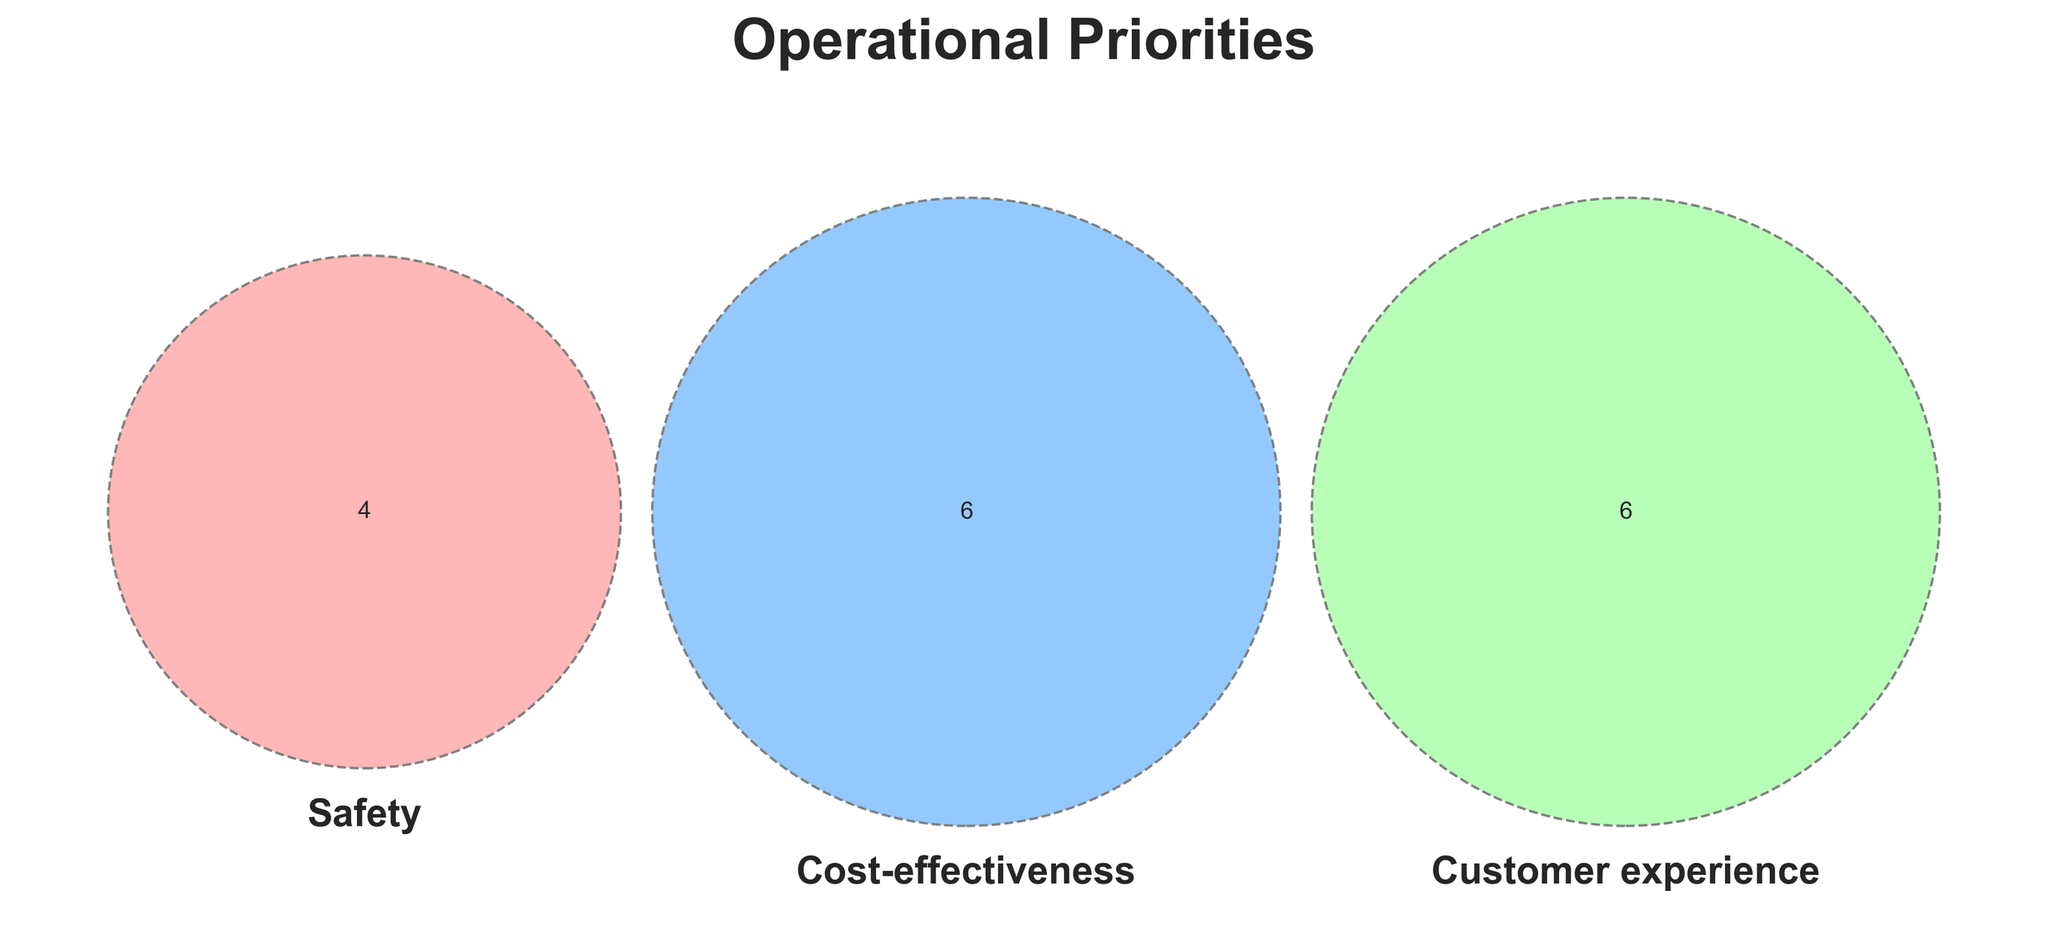How many priorities are unique to Safety? To determine this, we look at the area in the Venn diagram exclusively for Safety, which means not overlapping with Cost-effectiveness and Customer experience. These are "Emergency protocols", "Staff training", "Risk assessment", and "Evacuation plans".
Answer: 4 Which priorities are shared between Safety and Cost-effectiveness, but not Customer experience? This requires checking the overlap area between Safety and Cost-effectiveness that excludes Customer experience. In the Venn diagram, there are no elements in this overlapping section.
Answer: None What are the priorities that fall under Customer experience alone? We need to locate the area of the Venn diagram exclusive to Customer experience. These are "Personalized service", "Complaint resolution", "Guest feedback system", "Comfort amenities", and "Tailored itineraries".
Answer: 5 Are there any priorities shared by all three categories: Safety, Cost-effectiveness, and Customer experience? The center of the Venn diagram represents the intersection of all three categories. Since there is no mention of such an area in the dataset or the diagram, there are no shared priorities among all three.
Answer: None How many priorities are related to Cost-effectiveness, either exclusively or shared with other categories? This involves summing up all areas that include Cost-effectiveness. The priorities here are "Budget control", "Efficient resource allocation", "Vendor negotiations", "Cost-benefit analysis", "Inventory management", and "Bulk purchasing".
Answer: 6 Which category has the most unique priorities? By directly comparing the exclusive areas of each category in the Venn diagram. Safety has 4, Cost-effectiveness has 6, and Customer experience has 5 unique priorities.
Answer: Cost-effectiveness 